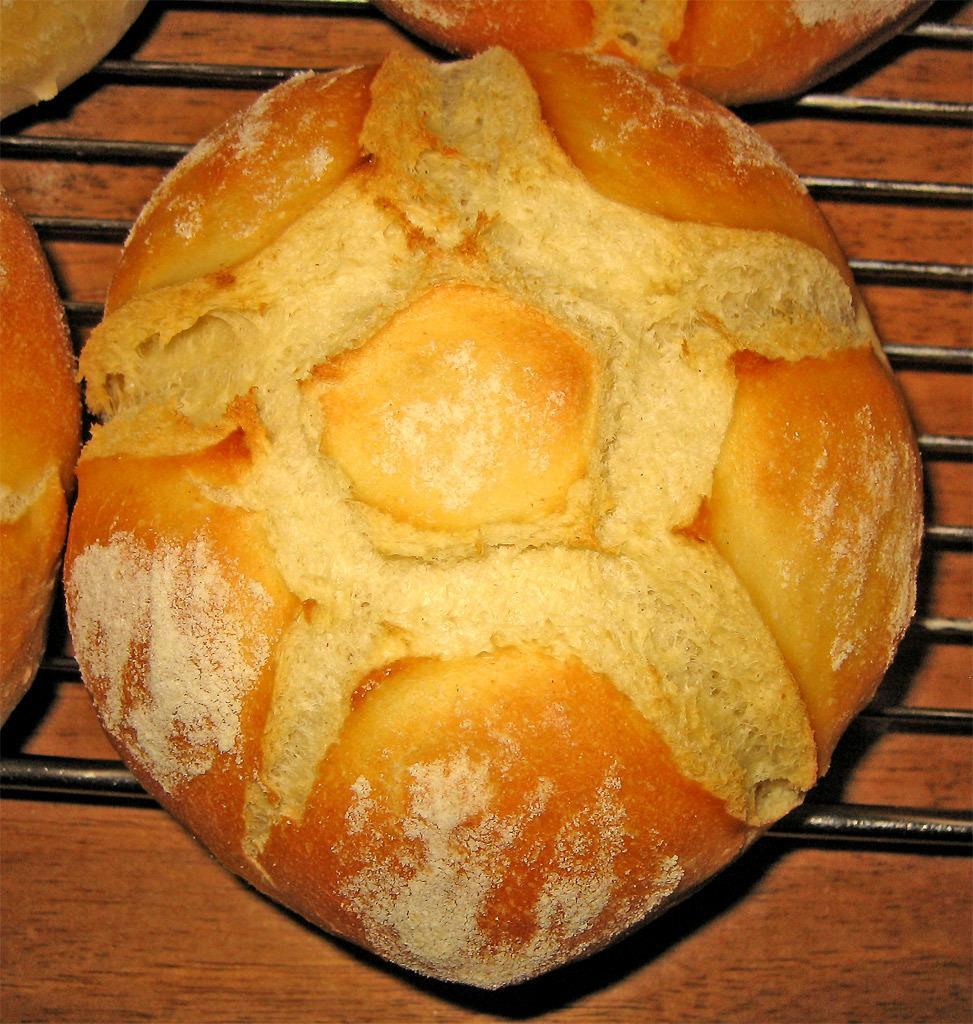Can you describe this image briefly? In this image I can see black colour grill rods and on it I can see brown and cream colour food. 